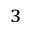<formula> <loc_0><loc_0><loc_500><loc_500>^ { 3 }</formula> 